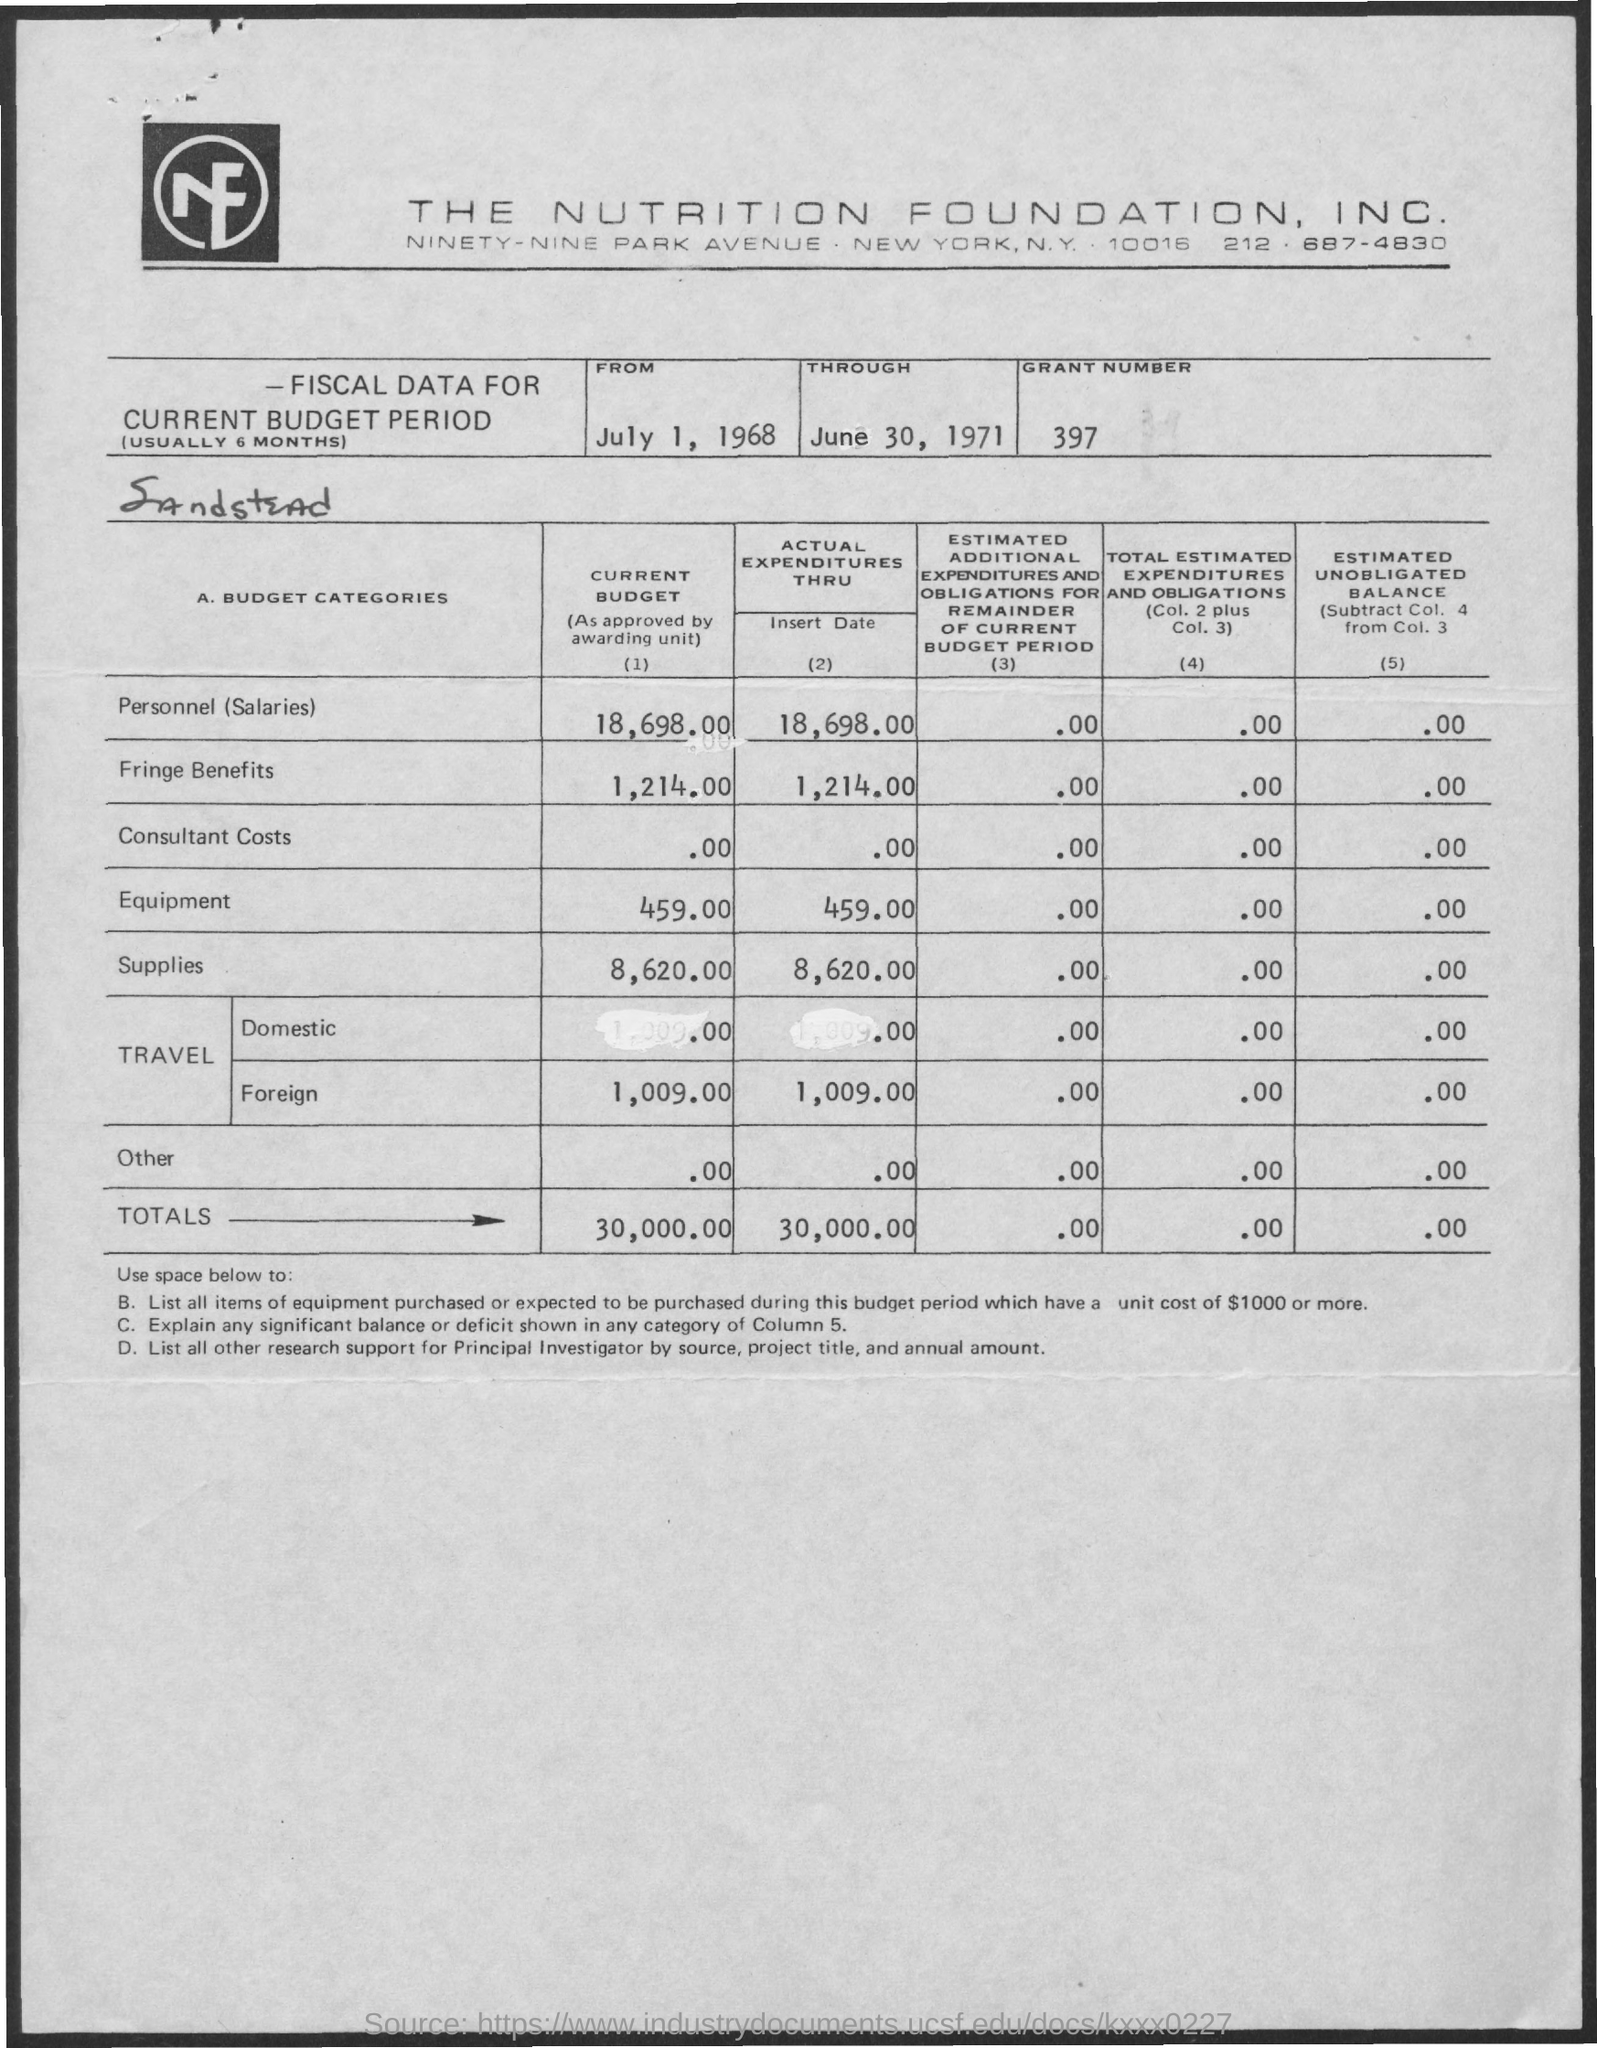List a handful of essential elements in this visual. The total amount shown in the actual expenditures is 30,000.00. The grant number mentioned on the given page is 397... The current budget includes the amount of personnel salaries, which is 18,698.00. The current budget shows a total amount of 30,000.00. The current budget includes fringe benefits amounting to 1,214.00. 